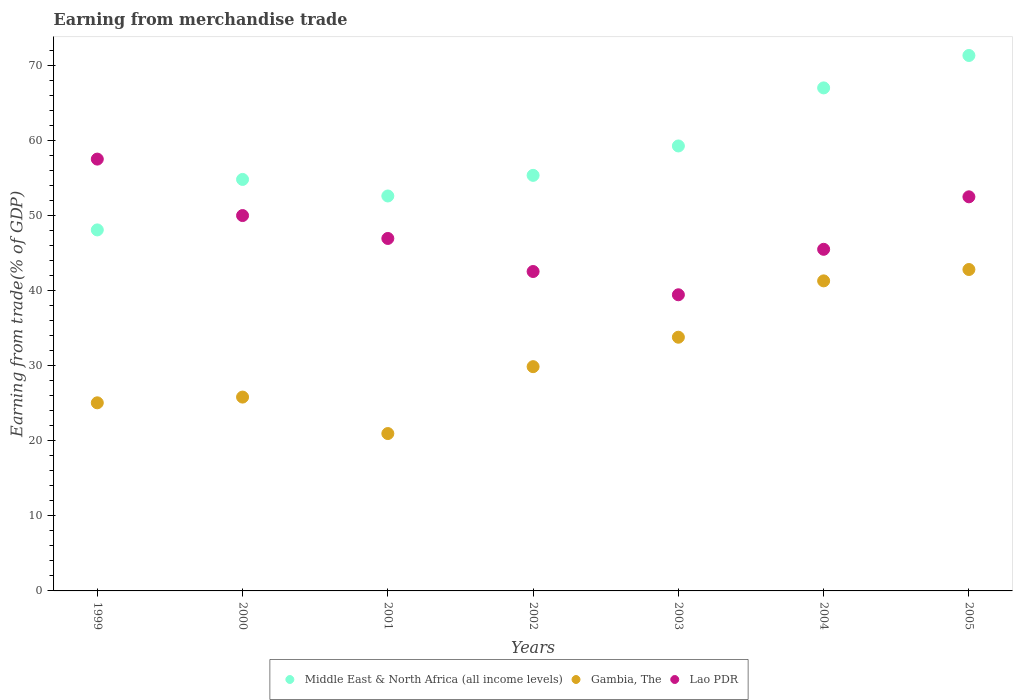What is the earnings from trade in Gambia, The in 2002?
Offer a very short reply. 29.85. Across all years, what is the maximum earnings from trade in Lao PDR?
Your answer should be compact. 57.48. Across all years, what is the minimum earnings from trade in Lao PDR?
Offer a very short reply. 39.42. What is the total earnings from trade in Lao PDR in the graph?
Your answer should be very brief. 334.23. What is the difference between the earnings from trade in Lao PDR in 1999 and that in 2004?
Provide a succinct answer. 12.01. What is the difference between the earnings from trade in Gambia, The in 2004 and the earnings from trade in Middle East & North Africa (all income levels) in 2002?
Provide a succinct answer. -14.04. What is the average earnings from trade in Gambia, The per year?
Make the answer very short. 31.35. In the year 2000, what is the difference between the earnings from trade in Middle East & North Africa (all income levels) and earnings from trade in Lao PDR?
Offer a terse response. 4.81. In how many years, is the earnings from trade in Lao PDR greater than 44 %?
Ensure brevity in your answer.  5. What is the ratio of the earnings from trade in Gambia, The in 2001 to that in 2003?
Offer a very short reply. 0.62. What is the difference between the highest and the second highest earnings from trade in Gambia, The?
Ensure brevity in your answer.  1.51. What is the difference between the highest and the lowest earnings from trade in Middle East & North Africa (all income levels)?
Provide a succinct answer. 23.22. Is it the case that in every year, the sum of the earnings from trade in Middle East & North Africa (all income levels) and earnings from trade in Gambia, The  is greater than the earnings from trade in Lao PDR?
Your answer should be compact. Yes. Does the earnings from trade in Middle East & North Africa (all income levels) monotonically increase over the years?
Your answer should be very brief. No. Is the earnings from trade in Lao PDR strictly less than the earnings from trade in Gambia, The over the years?
Offer a terse response. No. What is the difference between two consecutive major ticks on the Y-axis?
Ensure brevity in your answer.  10. Where does the legend appear in the graph?
Provide a short and direct response. Bottom center. What is the title of the graph?
Provide a short and direct response. Earning from merchandise trade. Does "West Bank and Gaza" appear as one of the legend labels in the graph?
Your answer should be very brief. No. What is the label or title of the Y-axis?
Ensure brevity in your answer.  Earning from trade(% of GDP). What is the Earning from trade(% of GDP) in Middle East & North Africa (all income levels) in 1999?
Make the answer very short. 48.05. What is the Earning from trade(% of GDP) of Gambia, The in 1999?
Keep it short and to the point. 25.04. What is the Earning from trade(% of GDP) of Lao PDR in 1999?
Keep it short and to the point. 57.48. What is the Earning from trade(% of GDP) in Middle East & North Africa (all income levels) in 2000?
Your answer should be very brief. 54.77. What is the Earning from trade(% of GDP) in Gambia, The in 2000?
Your answer should be very brief. 25.8. What is the Earning from trade(% of GDP) in Lao PDR in 2000?
Ensure brevity in your answer.  49.97. What is the Earning from trade(% of GDP) in Middle East & North Africa (all income levels) in 2001?
Make the answer very short. 52.57. What is the Earning from trade(% of GDP) in Gambia, The in 2001?
Offer a terse response. 20.95. What is the Earning from trade(% of GDP) in Lao PDR in 2001?
Provide a short and direct response. 46.92. What is the Earning from trade(% of GDP) of Middle East & North Africa (all income levels) in 2002?
Offer a very short reply. 55.32. What is the Earning from trade(% of GDP) of Gambia, The in 2002?
Offer a terse response. 29.85. What is the Earning from trade(% of GDP) of Lao PDR in 2002?
Your answer should be very brief. 42.52. What is the Earning from trade(% of GDP) of Middle East & North Africa (all income levels) in 2003?
Provide a short and direct response. 59.23. What is the Earning from trade(% of GDP) of Gambia, The in 2003?
Your answer should be compact. 33.77. What is the Earning from trade(% of GDP) of Lao PDR in 2003?
Your answer should be compact. 39.42. What is the Earning from trade(% of GDP) in Middle East & North Africa (all income levels) in 2004?
Provide a short and direct response. 66.96. What is the Earning from trade(% of GDP) of Gambia, The in 2004?
Provide a succinct answer. 41.27. What is the Earning from trade(% of GDP) of Lao PDR in 2004?
Your answer should be compact. 45.47. What is the Earning from trade(% of GDP) of Middle East & North Africa (all income levels) in 2005?
Provide a short and direct response. 71.27. What is the Earning from trade(% of GDP) in Gambia, The in 2005?
Your answer should be very brief. 42.78. What is the Earning from trade(% of GDP) of Lao PDR in 2005?
Offer a very short reply. 52.46. Across all years, what is the maximum Earning from trade(% of GDP) in Middle East & North Africa (all income levels)?
Provide a short and direct response. 71.27. Across all years, what is the maximum Earning from trade(% of GDP) in Gambia, The?
Provide a succinct answer. 42.78. Across all years, what is the maximum Earning from trade(% of GDP) of Lao PDR?
Your answer should be compact. 57.48. Across all years, what is the minimum Earning from trade(% of GDP) of Middle East & North Africa (all income levels)?
Offer a terse response. 48.05. Across all years, what is the minimum Earning from trade(% of GDP) of Gambia, The?
Offer a terse response. 20.95. Across all years, what is the minimum Earning from trade(% of GDP) in Lao PDR?
Keep it short and to the point. 39.42. What is the total Earning from trade(% of GDP) of Middle East & North Africa (all income levels) in the graph?
Provide a short and direct response. 408.17. What is the total Earning from trade(% of GDP) in Gambia, The in the graph?
Your answer should be very brief. 219.46. What is the total Earning from trade(% of GDP) in Lao PDR in the graph?
Offer a terse response. 334.23. What is the difference between the Earning from trade(% of GDP) of Middle East & North Africa (all income levels) in 1999 and that in 2000?
Keep it short and to the point. -6.72. What is the difference between the Earning from trade(% of GDP) of Gambia, The in 1999 and that in 2000?
Provide a succinct answer. -0.76. What is the difference between the Earning from trade(% of GDP) of Lao PDR in 1999 and that in 2000?
Keep it short and to the point. 7.51. What is the difference between the Earning from trade(% of GDP) in Middle East & North Africa (all income levels) in 1999 and that in 2001?
Offer a terse response. -4.52. What is the difference between the Earning from trade(% of GDP) of Gambia, The in 1999 and that in 2001?
Offer a terse response. 4.09. What is the difference between the Earning from trade(% of GDP) in Lao PDR in 1999 and that in 2001?
Your answer should be compact. 10.56. What is the difference between the Earning from trade(% of GDP) of Middle East & North Africa (all income levels) in 1999 and that in 2002?
Make the answer very short. -7.26. What is the difference between the Earning from trade(% of GDP) of Gambia, The in 1999 and that in 2002?
Give a very brief answer. -4.81. What is the difference between the Earning from trade(% of GDP) of Lao PDR in 1999 and that in 2002?
Offer a terse response. 14.96. What is the difference between the Earning from trade(% of GDP) of Middle East & North Africa (all income levels) in 1999 and that in 2003?
Provide a short and direct response. -11.17. What is the difference between the Earning from trade(% of GDP) of Gambia, The in 1999 and that in 2003?
Provide a short and direct response. -8.73. What is the difference between the Earning from trade(% of GDP) of Lao PDR in 1999 and that in 2003?
Your response must be concise. 18.06. What is the difference between the Earning from trade(% of GDP) of Middle East & North Africa (all income levels) in 1999 and that in 2004?
Offer a very short reply. -18.9. What is the difference between the Earning from trade(% of GDP) of Gambia, The in 1999 and that in 2004?
Provide a succinct answer. -16.23. What is the difference between the Earning from trade(% of GDP) in Lao PDR in 1999 and that in 2004?
Give a very brief answer. 12.01. What is the difference between the Earning from trade(% of GDP) in Middle East & North Africa (all income levels) in 1999 and that in 2005?
Give a very brief answer. -23.22. What is the difference between the Earning from trade(% of GDP) in Gambia, The in 1999 and that in 2005?
Offer a terse response. -17.74. What is the difference between the Earning from trade(% of GDP) of Lao PDR in 1999 and that in 2005?
Offer a very short reply. 5.02. What is the difference between the Earning from trade(% of GDP) in Middle East & North Africa (all income levels) in 2000 and that in 2001?
Your answer should be compact. 2.2. What is the difference between the Earning from trade(% of GDP) in Gambia, The in 2000 and that in 2001?
Offer a very short reply. 4.85. What is the difference between the Earning from trade(% of GDP) of Lao PDR in 2000 and that in 2001?
Provide a succinct answer. 3.05. What is the difference between the Earning from trade(% of GDP) in Middle East & North Africa (all income levels) in 2000 and that in 2002?
Offer a very short reply. -0.54. What is the difference between the Earning from trade(% of GDP) in Gambia, The in 2000 and that in 2002?
Provide a short and direct response. -4.05. What is the difference between the Earning from trade(% of GDP) of Lao PDR in 2000 and that in 2002?
Your answer should be compact. 7.45. What is the difference between the Earning from trade(% of GDP) of Middle East & North Africa (all income levels) in 2000 and that in 2003?
Provide a short and direct response. -4.46. What is the difference between the Earning from trade(% of GDP) of Gambia, The in 2000 and that in 2003?
Your answer should be compact. -7.97. What is the difference between the Earning from trade(% of GDP) in Lao PDR in 2000 and that in 2003?
Your response must be concise. 10.55. What is the difference between the Earning from trade(% of GDP) of Middle East & North Africa (all income levels) in 2000 and that in 2004?
Provide a succinct answer. -12.19. What is the difference between the Earning from trade(% of GDP) of Gambia, The in 2000 and that in 2004?
Your answer should be compact. -15.47. What is the difference between the Earning from trade(% of GDP) of Lao PDR in 2000 and that in 2004?
Provide a succinct answer. 4.49. What is the difference between the Earning from trade(% of GDP) in Middle East & North Africa (all income levels) in 2000 and that in 2005?
Your response must be concise. -16.5. What is the difference between the Earning from trade(% of GDP) of Gambia, The in 2000 and that in 2005?
Ensure brevity in your answer.  -16.98. What is the difference between the Earning from trade(% of GDP) in Lao PDR in 2000 and that in 2005?
Provide a succinct answer. -2.49. What is the difference between the Earning from trade(% of GDP) of Middle East & North Africa (all income levels) in 2001 and that in 2002?
Your response must be concise. -2.75. What is the difference between the Earning from trade(% of GDP) of Gambia, The in 2001 and that in 2002?
Offer a very short reply. -8.9. What is the difference between the Earning from trade(% of GDP) in Lao PDR in 2001 and that in 2002?
Make the answer very short. 4.4. What is the difference between the Earning from trade(% of GDP) of Middle East & North Africa (all income levels) in 2001 and that in 2003?
Offer a terse response. -6.66. What is the difference between the Earning from trade(% of GDP) in Gambia, The in 2001 and that in 2003?
Offer a terse response. -12.82. What is the difference between the Earning from trade(% of GDP) of Lao PDR in 2001 and that in 2003?
Provide a short and direct response. 7.5. What is the difference between the Earning from trade(% of GDP) in Middle East & North Africa (all income levels) in 2001 and that in 2004?
Offer a terse response. -14.39. What is the difference between the Earning from trade(% of GDP) of Gambia, The in 2001 and that in 2004?
Your response must be concise. -20.32. What is the difference between the Earning from trade(% of GDP) of Lao PDR in 2001 and that in 2004?
Provide a succinct answer. 1.44. What is the difference between the Earning from trade(% of GDP) in Middle East & North Africa (all income levels) in 2001 and that in 2005?
Give a very brief answer. -18.7. What is the difference between the Earning from trade(% of GDP) in Gambia, The in 2001 and that in 2005?
Make the answer very short. -21.84. What is the difference between the Earning from trade(% of GDP) of Lao PDR in 2001 and that in 2005?
Offer a terse response. -5.54. What is the difference between the Earning from trade(% of GDP) of Middle East & North Africa (all income levels) in 2002 and that in 2003?
Your answer should be compact. -3.91. What is the difference between the Earning from trade(% of GDP) in Gambia, The in 2002 and that in 2003?
Keep it short and to the point. -3.92. What is the difference between the Earning from trade(% of GDP) in Lao PDR in 2002 and that in 2003?
Give a very brief answer. 3.1. What is the difference between the Earning from trade(% of GDP) of Middle East & North Africa (all income levels) in 2002 and that in 2004?
Offer a very short reply. -11.64. What is the difference between the Earning from trade(% of GDP) in Gambia, The in 2002 and that in 2004?
Make the answer very short. -11.42. What is the difference between the Earning from trade(% of GDP) in Lao PDR in 2002 and that in 2004?
Provide a short and direct response. -2.96. What is the difference between the Earning from trade(% of GDP) of Middle East & North Africa (all income levels) in 2002 and that in 2005?
Offer a terse response. -15.96. What is the difference between the Earning from trade(% of GDP) in Gambia, The in 2002 and that in 2005?
Your answer should be very brief. -12.93. What is the difference between the Earning from trade(% of GDP) in Lao PDR in 2002 and that in 2005?
Keep it short and to the point. -9.94. What is the difference between the Earning from trade(% of GDP) of Middle East & North Africa (all income levels) in 2003 and that in 2004?
Ensure brevity in your answer.  -7.73. What is the difference between the Earning from trade(% of GDP) of Gambia, The in 2003 and that in 2004?
Make the answer very short. -7.5. What is the difference between the Earning from trade(% of GDP) in Lao PDR in 2003 and that in 2004?
Offer a terse response. -6.05. What is the difference between the Earning from trade(% of GDP) in Middle East & North Africa (all income levels) in 2003 and that in 2005?
Provide a succinct answer. -12.04. What is the difference between the Earning from trade(% of GDP) of Gambia, The in 2003 and that in 2005?
Provide a succinct answer. -9.01. What is the difference between the Earning from trade(% of GDP) of Lao PDR in 2003 and that in 2005?
Your response must be concise. -13.04. What is the difference between the Earning from trade(% of GDP) of Middle East & North Africa (all income levels) in 2004 and that in 2005?
Keep it short and to the point. -4.32. What is the difference between the Earning from trade(% of GDP) in Gambia, The in 2004 and that in 2005?
Provide a short and direct response. -1.51. What is the difference between the Earning from trade(% of GDP) of Lao PDR in 2004 and that in 2005?
Provide a short and direct response. -6.99. What is the difference between the Earning from trade(% of GDP) in Middle East & North Africa (all income levels) in 1999 and the Earning from trade(% of GDP) in Gambia, The in 2000?
Your response must be concise. 22.25. What is the difference between the Earning from trade(% of GDP) in Middle East & North Africa (all income levels) in 1999 and the Earning from trade(% of GDP) in Lao PDR in 2000?
Offer a very short reply. -1.91. What is the difference between the Earning from trade(% of GDP) in Gambia, The in 1999 and the Earning from trade(% of GDP) in Lao PDR in 2000?
Ensure brevity in your answer.  -24.93. What is the difference between the Earning from trade(% of GDP) in Middle East & North Africa (all income levels) in 1999 and the Earning from trade(% of GDP) in Gambia, The in 2001?
Give a very brief answer. 27.11. What is the difference between the Earning from trade(% of GDP) of Middle East & North Africa (all income levels) in 1999 and the Earning from trade(% of GDP) of Lao PDR in 2001?
Provide a succinct answer. 1.14. What is the difference between the Earning from trade(% of GDP) of Gambia, The in 1999 and the Earning from trade(% of GDP) of Lao PDR in 2001?
Make the answer very short. -21.88. What is the difference between the Earning from trade(% of GDP) in Middle East & North Africa (all income levels) in 1999 and the Earning from trade(% of GDP) in Gambia, The in 2002?
Make the answer very short. 18.2. What is the difference between the Earning from trade(% of GDP) of Middle East & North Africa (all income levels) in 1999 and the Earning from trade(% of GDP) of Lao PDR in 2002?
Make the answer very short. 5.54. What is the difference between the Earning from trade(% of GDP) of Gambia, The in 1999 and the Earning from trade(% of GDP) of Lao PDR in 2002?
Make the answer very short. -17.48. What is the difference between the Earning from trade(% of GDP) of Middle East & North Africa (all income levels) in 1999 and the Earning from trade(% of GDP) of Gambia, The in 2003?
Provide a succinct answer. 14.28. What is the difference between the Earning from trade(% of GDP) in Middle East & North Africa (all income levels) in 1999 and the Earning from trade(% of GDP) in Lao PDR in 2003?
Give a very brief answer. 8.63. What is the difference between the Earning from trade(% of GDP) in Gambia, The in 1999 and the Earning from trade(% of GDP) in Lao PDR in 2003?
Ensure brevity in your answer.  -14.38. What is the difference between the Earning from trade(% of GDP) in Middle East & North Africa (all income levels) in 1999 and the Earning from trade(% of GDP) in Gambia, The in 2004?
Your answer should be compact. 6.78. What is the difference between the Earning from trade(% of GDP) of Middle East & North Africa (all income levels) in 1999 and the Earning from trade(% of GDP) of Lao PDR in 2004?
Give a very brief answer. 2.58. What is the difference between the Earning from trade(% of GDP) in Gambia, The in 1999 and the Earning from trade(% of GDP) in Lao PDR in 2004?
Your answer should be very brief. -20.43. What is the difference between the Earning from trade(% of GDP) in Middle East & North Africa (all income levels) in 1999 and the Earning from trade(% of GDP) in Gambia, The in 2005?
Your response must be concise. 5.27. What is the difference between the Earning from trade(% of GDP) of Middle East & North Africa (all income levels) in 1999 and the Earning from trade(% of GDP) of Lao PDR in 2005?
Offer a terse response. -4.4. What is the difference between the Earning from trade(% of GDP) of Gambia, The in 1999 and the Earning from trade(% of GDP) of Lao PDR in 2005?
Keep it short and to the point. -27.42. What is the difference between the Earning from trade(% of GDP) in Middle East & North Africa (all income levels) in 2000 and the Earning from trade(% of GDP) in Gambia, The in 2001?
Your response must be concise. 33.83. What is the difference between the Earning from trade(% of GDP) in Middle East & North Africa (all income levels) in 2000 and the Earning from trade(% of GDP) in Lao PDR in 2001?
Your response must be concise. 7.86. What is the difference between the Earning from trade(% of GDP) in Gambia, The in 2000 and the Earning from trade(% of GDP) in Lao PDR in 2001?
Provide a succinct answer. -21.12. What is the difference between the Earning from trade(% of GDP) in Middle East & North Africa (all income levels) in 2000 and the Earning from trade(% of GDP) in Gambia, The in 2002?
Your answer should be very brief. 24.92. What is the difference between the Earning from trade(% of GDP) in Middle East & North Africa (all income levels) in 2000 and the Earning from trade(% of GDP) in Lao PDR in 2002?
Offer a terse response. 12.26. What is the difference between the Earning from trade(% of GDP) in Gambia, The in 2000 and the Earning from trade(% of GDP) in Lao PDR in 2002?
Provide a succinct answer. -16.72. What is the difference between the Earning from trade(% of GDP) of Middle East & North Africa (all income levels) in 2000 and the Earning from trade(% of GDP) of Gambia, The in 2003?
Offer a very short reply. 21. What is the difference between the Earning from trade(% of GDP) of Middle East & North Africa (all income levels) in 2000 and the Earning from trade(% of GDP) of Lao PDR in 2003?
Offer a terse response. 15.35. What is the difference between the Earning from trade(% of GDP) in Gambia, The in 2000 and the Earning from trade(% of GDP) in Lao PDR in 2003?
Offer a terse response. -13.62. What is the difference between the Earning from trade(% of GDP) of Middle East & North Africa (all income levels) in 2000 and the Earning from trade(% of GDP) of Gambia, The in 2004?
Make the answer very short. 13.5. What is the difference between the Earning from trade(% of GDP) in Middle East & North Africa (all income levels) in 2000 and the Earning from trade(% of GDP) in Lao PDR in 2004?
Offer a terse response. 9.3. What is the difference between the Earning from trade(% of GDP) in Gambia, The in 2000 and the Earning from trade(% of GDP) in Lao PDR in 2004?
Offer a terse response. -19.67. What is the difference between the Earning from trade(% of GDP) in Middle East & North Africa (all income levels) in 2000 and the Earning from trade(% of GDP) in Gambia, The in 2005?
Your answer should be compact. 11.99. What is the difference between the Earning from trade(% of GDP) in Middle East & North Africa (all income levels) in 2000 and the Earning from trade(% of GDP) in Lao PDR in 2005?
Provide a succinct answer. 2.31. What is the difference between the Earning from trade(% of GDP) in Gambia, The in 2000 and the Earning from trade(% of GDP) in Lao PDR in 2005?
Make the answer very short. -26.66. What is the difference between the Earning from trade(% of GDP) in Middle East & North Africa (all income levels) in 2001 and the Earning from trade(% of GDP) in Gambia, The in 2002?
Make the answer very short. 22.72. What is the difference between the Earning from trade(% of GDP) in Middle East & North Africa (all income levels) in 2001 and the Earning from trade(% of GDP) in Lao PDR in 2002?
Your answer should be very brief. 10.05. What is the difference between the Earning from trade(% of GDP) in Gambia, The in 2001 and the Earning from trade(% of GDP) in Lao PDR in 2002?
Offer a terse response. -21.57. What is the difference between the Earning from trade(% of GDP) of Middle East & North Africa (all income levels) in 2001 and the Earning from trade(% of GDP) of Gambia, The in 2003?
Make the answer very short. 18.8. What is the difference between the Earning from trade(% of GDP) in Middle East & North Africa (all income levels) in 2001 and the Earning from trade(% of GDP) in Lao PDR in 2003?
Your answer should be very brief. 13.15. What is the difference between the Earning from trade(% of GDP) in Gambia, The in 2001 and the Earning from trade(% of GDP) in Lao PDR in 2003?
Your response must be concise. -18.47. What is the difference between the Earning from trade(% of GDP) in Middle East & North Africa (all income levels) in 2001 and the Earning from trade(% of GDP) in Gambia, The in 2004?
Your answer should be very brief. 11.3. What is the difference between the Earning from trade(% of GDP) of Middle East & North Africa (all income levels) in 2001 and the Earning from trade(% of GDP) of Lao PDR in 2004?
Ensure brevity in your answer.  7.1. What is the difference between the Earning from trade(% of GDP) in Gambia, The in 2001 and the Earning from trade(% of GDP) in Lao PDR in 2004?
Give a very brief answer. -24.52. What is the difference between the Earning from trade(% of GDP) of Middle East & North Africa (all income levels) in 2001 and the Earning from trade(% of GDP) of Gambia, The in 2005?
Your response must be concise. 9.79. What is the difference between the Earning from trade(% of GDP) of Middle East & North Africa (all income levels) in 2001 and the Earning from trade(% of GDP) of Lao PDR in 2005?
Provide a succinct answer. 0.11. What is the difference between the Earning from trade(% of GDP) in Gambia, The in 2001 and the Earning from trade(% of GDP) in Lao PDR in 2005?
Your answer should be compact. -31.51. What is the difference between the Earning from trade(% of GDP) in Middle East & North Africa (all income levels) in 2002 and the Earning from trade(% of GDP) in Gambia, The in 2003?
Your response must be concise. 21.55. What is the difference between the Earning from trade(% of GDP) of Middle East & North Africa (all income levels) in 2002 and the Earning from trade(% of GDP) of Lao PDR in 2003?
Provide a short and direct response. 15.9. What is the difference between the Earning from trade(% of GDP) in Gambia, The in 2002 and the Earning from trade(% of GDP) in Lao PDR in 2003?
Your answer should be compact. -9.57. What is the difference between the Earning from trade(% of GDP) of Middle East & North Africa (all income levels) in 2002 and the Earning from trade(% of GDP) of Gambia, The in 2004?
Provide a succinct answer. 14.04. What is the difference between the Earning from trade(% of GDP) in Middle East & North Africa (all income levels) in 2002 and the Earning from trade(% of GDP) in Lao PDR in 2004?
Make the answer very short. 9.84. What is the difference between the Earning from trade(% of GDP) of Gambia, The in 2002 and the Earning from trade(% of GDP) of Lao PDR in 2004?
Your response must be concise. -15.62. What is the difference between the Earning from trade(% of GDP) of Middle East & North Africa (all income levels) in 2002 and the Earning from trade(% of GDP) of Gambia, The in 2005?
Your response must be concise. 12.53. What is the difference between the Earning from trade(% of GDP) of Middle East & North Africa (all income levels) in 2002 and the Earning from trade(% of GDP) of Lao PDR in 2005?
Give a very brief answer. 2.86. What is the difference between the Earning from trade(% of GDP) of Gambia, The in 2002 and the Earning from trade(% of GDP) of Lao PDR in 2005?
Keep it short and to the point. -22.61. What is the difference between the Earning from trade(% of GDP) of Middle East & North Africa (all income levels) in 2003 and the Earning from trade(% of GDP) of Gambia, The in 2004?
Provide a succinct answer. 17.96. What is the difference between the Earning from trade(% of GDP) of Middle East & North Africa (all income levels) in 2003 and the Earning from trade(% of GDP) of Lao PDR in 2004?
Offer a terse response. 13.76. What is the difference between the Earning from trade(% of GDP) of Gambia, The in 2003 and the Earning from trade(% of GDP) of Lao PDR in 2004?
Keep it short and to the point. -11.7. What is the difference between the Earning from trade(% of GDP) in Middle East & North Africa (all income levels) in 2003 and the Earning from trade(% of GDP) in Gambia, The in 2005?
Your response must be concise. 16.45. What is the difference between the Earning from trade(% of GDP) in Middle East & North Africa (all income levels) in 2003 and the Earning from trade(% of GDP) in Lao PDR in 2005?
Keep it short and to the point. 6.77. What is the difference between the Earning from trade(% of GDP) in Gambia, The in 2003 and the Earning from trade(% of GDP) in Lao PDR in 2005?
Make the answer very short. -18.69. What is the difference between the Earning from trade(% of GDP) of Middle East & North Africa (all income levels) in 2004 and the Earning from trade(% of GDP) of Gambia, The in 2005?
Ensure brevity in your answer.  24.18. What is the difference between the Earning from trade(% of GDP) in Middle East & North Africa (all income levels) in 2004 and the Earning from trade(% of GDP) in Lao PDR in 2005?
Provide a short and direct response. 14.5. What is the difference between the Earning from trade(% of GDP) in Gambia, The in 2004 and the Earning from trade(% of GDP) in Lao PDR in 2005?
Keep it short and to the point. -11.19. What is the average Earning from trade(% of GDP) in Middle East & North Africa (all income levels) per year?
Ensure brevity in your answer.  58.31. What is the average Earning from trade(% of GDP) in Gambia, The per year?
Your answer should be very brief. 31.35. What is the average Earning from trade(% of GDP) of Lao PDR per year?
Offer a very short reply. 47.75. In the year 1999, what is the difference between the Earning from trade(% of GDP) of Middle East & North Africa (all income levels) and Earning from trade(% of GDP) of Gambia, The?
Offer a terse response. 23.02. In the year 1999, what is the difference between the Earning from trade(% of GDP) in Middle East & North Africa (all income levels) and Earning from trade(% of GDP) in Lao PDR?
Your response must be concise. -9.43. In the year 1999, what is the difference between the Earning from trade(% of GDP) of Gambia, The and Earning from trade(% of GDP) of Lao PDR?
Ensure brevity in your answer.  -32.44. In the year 2000, what is the difference between the Earning from trade(% of GDP) of Middle East & North Africa (all income levels) and Earning from trade(% of GDP) of Gambia, The?
Your response must be concise. 28.97. In the year 2000, what is the difference between the Earning from trade(% of GDP) of Middle East & North Africa (all income levels) and Earning from trade(% of GDP) of Lao PDR?
Offer a terse response. 4.81. In the year 2000, what is the difference between the Earning from trade(% of GDP) in Gambia, The and Earning from trade(% of GDP) in Lao PDR?
Your answer should be very brief. -24.16. In the year 2001, what is the difference between the Earning from trade(% of GDP) of Middle East & North Africa (all income levels) and Earning from trade(% of GDP) of Gambia, The?
Your answer should be compact. 31.62. In the year 2001, what is the difference between the Earning from trade(% of GDP) of Middle East & North Africa (all income levels) and Earning from trade(% of GDP) of Lao PDR?
Provide a succinct answer. 5.65. In the year 2001, what is the difference between the Earning from trade(% of GDP) in Gambia, The and Earning from trade(% of GDP) in Lao PDR?
Make the answer very short. -25.97. In the year 2002, what is the difference between the Earning from trade(% of GDP) in Middle East & North Africa (all income levels) and Earning from trade(% of GDP) in Gambia, The?
Keep it short and to the point. 25.46. In the year 2002, what is the difference between the Earning from trade(% of GDP) of Middle East & North Africa (all income levels) and Earning from trade(% of GDP) of Lao PDR?
Keep it short and to the point. 12.8. In the year 2002, what is the difference between the Earning from trade(% of GDP) in Gambia, The and Earning from trade(% of GDP) in Lao PDR?
Provide a short and direct response. -12.67. In the year 2003, what is the difference between the Earning from trade(% of GDP) in Middle East & North Africa (all income levels) and Earning from trade(% of GDP) in Gambia, The?
Your answer should be compact. 25.46. In the year 2003, what is the difference between the Earning from trade(% of GDP) of Middle East & North Africa (all income levels) and Earning from trade(% of GDP) of Lao PDR?
Ensure brevity in your answer.  19.81. In the year 2003, what is the difference between the Earning from trade(% of GDP) in Gambia, The and Earning from trade(% of GDP) in Lao PDR?
Make the answer very short. -5.65. In the year 2004, what is the difference between the Earning from trade(% of GDP) of Middle East & North Africa (all income levels) and Earning from trade(% of GDP) of Gambia, The?
Give a very brief answer. 25.69. In the year 2004, what is the difference between the Earning from trade(% of GDP) in Middle East & North Africa (all income levels) and Earning from trade(% of GDP) in Lao PDR?
Offer a very short reply. 21.49. In the year 2004, what is the difference between the Earning from trade(% of GDP) in Gambia, The and Earning from trade(% of GDP) in Lao PDR?
Your answer should be very brief. -4.2. In the year 2005, what is the difference between the Earning from trade(% of GDP) of Middle East & North Africa (all income levels) and Earning from trade(% of GDP) of Gambia, The?
Make the answer very short. 28.49. In the year 2005, what is the difference between the Earning from trade(% of GDP) in Middle East & North Africa (all income levels) and Earning from trade(% of GDP) in Lao PDR?
Offer a very short reply. 18.81. In the year 2005, what is the difference between the Earning from trade(% of GDP) of Gambia, The and Earning from trade(% of GDP) of Lao PDR?
Give a very brief answer. -9.68. What is the ratio of the Earning from trade(% of GDP) in Middle East & North Africa (all income levels) in 1999 to that in 2000?
Your answer should be very brief. 0.88. What is the ratio of the Earning from trade(% of GDP) in Gambia, The in 1999 to that in 2000?
Ensure brevity in your answer.  0.97. What is the ratio of the Earning from trade(% of GDP) in Lao PDR in 1999 to that in 2000?
Give a very brief answer. 1.15. What is the ratio of the Earning from trade(% of GDP) of Middle East & North Africa (all income levels) in 1999 to that in 2001?
Provide a short and direct response. 0.91. What is the ratio of the Earning from trade(% of GDP) in Gambia, The in 1999 to that in 2001?
Keep it short and to the point. 1.2. What is the ratio of the Earning from trade(% of GDP) of Lao PDR in 1999 to that in 2001?
Offer a very short reply. 1.23. What is the ratio of the Earning from trade(% of GDP) in Middle East & North Africa (all income levels) in 1999 to that in 2002?
Give a very brief answer. 0.87. What is the ratio of the Earning from trade(% of GDP) of Gambia, The in 1999 to that in 2002?
Keep it short and to the point. 0.84. What is the ratio of the Earning from trade(% of GDP) in Lao PDR in 1999 to that in 2002?
Give a very brief answer. 1.35. What is the ratio of the Earning from trade(% of GDP) of Middle East & North Africa (all income levels) in 1999 to that in 2003?
Offer a terse response. 0.81. What is the ratio of the Earning from trade(% of GDP) of Gambia, The in 1999 to that in 2003?
Make the answer very short. 0.74. What is the ratio of the Earning from trade(% of GDP) in Lao PDR in 1999 to that in 2003?
Ensure brevity in your answer.  1.46. What is the ratio of the Earning from trade(% of GDP) of Middle East & North Africa (all income levels) in 1999 to that in 2004?
Your answer should be very brief. 0.72. What is the ratio of the Earning from trade(% of GDP) of Gambia, The in 1999 to that in 2004?
Provide a succinct answer. 0.61. What is the ratio of the Earning from trade(% of GDP) of Lao PDR in 1999 to that in 2004?
Ensure brevity in your answer.  1.26. What is the ratio of the Earning from trade(% of GDP) of Middle East & North Africa (all income levels) in 1999 to that in 2005?
Provide a short and direct response. 0.67. What is the ratio of the Earning from trade(% of GDP) in Gambia, The in 1999 to that in 2005?
Keep it short and to the point. 0.59. What is the ratio of the Earning from trade(% of GDP) of Lao PDR in 1999 to that in 2005?
Provide a succinct answer. 1.1. What is the ratio of the Earning from trade(% of GDP) in Middle East & North Africa (all income levels) in 2000 to that in 2001?
Your answer should be very brief. 1.04. What is the ratio of the Earning from trade(% of GDP) of Gambia, The in 2000 to that in 2001?
Offer a terse response. 1.23. What is the ratio of the Earning from trade(% of GDP) of Lao PDR in 2000 to that in 2001?
Offer a very short reply. 1.06. What is the ratio of the Earning from trade(% of GDP) in Middle East & North Africa (all income levels) in 2000 to that in 2002?
Give a very brief answer. 0.99. What is the ratio of the Earning from trade(% of GDP) in Gambia, The in 2000 to that in 2002?
Provide a succinct answer. 0.86. What is the ratio of the Earning from trade(% of GDP) in Lao PDR in 2000 to that in 2002?
Provide a short and direct response. 1.18. What is the ratio of the Earning from trade(% of GDP) of Middle East & North Africa (all income levels) in 2000 to that in 2003?
Offer a terse response. 0.92. What is the ratio of the Earning from trade(% of GDP) in Gambia, The in 2000 to that in 2003?
Your answer should be compact. 0.76. What is the ratio of the Earning from trade(% of GDP) in Lao PDR in 2000 to that in 2003?
Your answer should be very brief. 1.27. What is the ratio of the Earning from trade(% of GDP) in Middle East & North Africa (all income levels) in 2000 to that in 2004?
Your answer should be compact. 0.82. What is the ratio of the Earning from trade(% of GDP) in Gambia, The in 2000 to that in 2004?
Your response must be concise. 0.63. What is the ratio of the Earning from trade(% of GDP) in Lao PDR in 2000 to that in 2004?
Your response must be concise. 1.1. What is the ratio of the Earning from trade(% of GDP) of Middle East & North Africa (all income levels) in 2000 to that in 2005?
Your answer should be compact. 0.77. What is the ratio of the Earning from trade(% of GDP) in Gambia, The in 2000 to that in 2005?
Your response must be concise. 0.6. What is the ratio of the Earning from trade(% of GDP) of Lao PDR in 2000 to that in 2005?
Offer a very short reply. 0.95. What is the ratio of the Earning from trade(% of GDP) in Middle East & North Africa (all income levels) in 2001 to that in 2002?
Keep it short and to the point. 0.95. What is the ratio of the Earning from trade(% of GDP) in Gambia, The in 2001 to that in 2002?
Your response must be concise. 0.7. What is the ratio of the Earning from trade(% of GDP) in Lao PDR in 2001 to that in 2002?
Your answer should be very brief. 1.1. What is the ratio of the Earning from trade(% of GDP) in Middle East & North Africa (all income levels) in 2001 to that in 2003?
Provide a short and direct response. 0.89. What is the ratio of the Earning from trade(% of GDP) of Gambia, The in 2001 to that in 2003?
Your answer should be very brief. 0.62. What is the ratio of the Earning from trade(% of GDP) of Lao PDR in 2001 to that in 2003?
Your answer should be compact. 1.19. What is the ratio of the Earning from trade(% of GDP) in Middle East & North Africa (all income levels) in 2001 to that in 2004?
Provide a succinct answer. 0.79. What is the ratio of the Earning from trade(% of GDP) in Gambia, The in 2001 to that in 2004?
Offer a terse response. 0.51. What is the ratio of the Earning from trade(% of GDP) in Lao PDR in 2001 to that in 2004?
Offer a very short reply. 1.03. What is the ratio of the Earning from trade(% of GDP) in Middle East & North Africa (all income levels) in 2001 to that in 2005?
Make the answer very short. 0.74. What is the ratio of the Earning from trade(% of GDP) of Gambia, The in 2001 to that in 2005?
Provide a succinct answer. 0.49. What is the ratio of the Earning from trade(% of GDP) in Lao PDR in 2001 to that in 2005?
Make the answer very short. 0.89. What is the ratio of the Earning from trade(% of GDP) in Middle East & North Africa (all income levels) in 2002 to that in 2003?
Your answer should be very brief. 0.93. What is the ratio of the Earning from trade(% of GDP) of Gambia, The in 2002 to that in 2003?
Give a very brief answer. 0.88. What is the ratio of the Earning from trade(% of GDP) of Lao PDR in 2002 to that in 2003?
Ensure brevity in your answer.  1.08. What is the ratio of the Earning from trade(% of GDP) in Middle East & North Africa (all income levels) in 2002 to that in 2004?
Offer a very short reply. 0.83. What is the ratio of the Earning from trade(% of GDP) in Gambia, The in 2002 to that in 2004?
Provide a short and direct response. 0.72. What is the ratio of the Earning from trade(% of GDP) of Lao PDR in 2002 to that in 2004?
Provide a succinct answer. 0.94. What is the ratio of the Earning from trade(% of GDP) in Middle East & North Africa (all income levels) in 2002 to that in 2005?
Ensure brevity in your answer.  0.78. What is the ratio of the Earning from trade(% of GDP) of Gambia, The in 2002 to that in 2005?
Offer a terse response. 0.7. What is the ratio of the Earning from trade(% of GDP) of Lao PDR in 2002 to that in 2005?
Keep it short and to the point. 0.81. What is the ratio of the Earning from trade(% of GDP) of Middle East & North Africa (all income levels) in 2003 to that in 2004?
Provide a succinct answer. 0.88. What is the ratio of the Earning from trade(% of GDP) of Gambia, The in 2003 to that in 2004?
Provide a succinct answer. 0.82. What is the ratio of the Earning from trade(% of GDP) of Lao PDR in 2003 to that in 2004?
Your answer should be very brief. 0.87. What is the ratio of the Earning from trade(% of GDP) of Middle East & North Africa (all income levels) in 2003 to that in 2005?
Your response must be concise. 0.83. What is the ratio of the Earning from trade(% of GDP) in Gambia, The in 2003 to that in 2005?
Your response must be concise. 0.79. What is the ratio of the Earning from trade(% of GDP) of Lao PDR in 2003 to that in 2005?
Provide a short and direct response. 0.75. What is the ratio of the Earning from trade(% of GDP) in Middle East & North Africa (all income levels) in 2004 to that in 2005?
Your answer should be compact. 0.94. What is the ratio of the Earning from trade(% of GDP) of Gambia, The in 2004 to that in 2005?
Your answer should be very brief. 0.96. What is the ratio of the Earning from trade(% of GDP) in Lao PDR in 2004 to that in 2005?
Your answer should be compact. 0.87. What is the difference between the highest and the second highest Earning from trade(% of GDP) in Middle East & North Africa (all income levels)?
Offer a terse response. 4.32. What is the difference between the highest and the second highest Earning from trade(% of GDP) in Gambia, The?
Provide a short and direct response. 1.51. What is the difference between the highest and the second highest Earning from trade(% of GDP) of Lao PDR?
Give a very brief answer. 5.02. What is the difference between the highest and the lowest Earning from trade(% of GDP) of Middle East & North Africa (all income levels)?
Provide a succinct answer. 23.22. What is the difference between the highest and the lowest Earning from trade(% of GDP) of Gambia, The?
Make the answer very short. 21.84. What is the difference between the highest and the lowest Earning from trade(% of GDP) in Lao PDR?
Give a very brief answer. 18.06. 